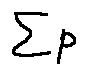<formula> <loc_0><loc_0><loc_500><loc_500>\sum P</formula> 